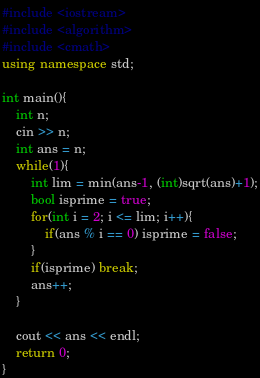Convert code to text. <code><loc_0><loc_0><loc_500><loc_500><_C++_>#include <iostream>
#include <algorithm>
#include <cmath>
using namespace std;

int main(){
    int n;
    cin >> n;
    int ans = n;
    while(1){
        int lim = min(ans-1, (int)sqrt(ans)+1);
        bool isprime = true;
        for(int i = 2; i <= lim; i++){
            if(ans % i == 0) isprime = false;
        }
        if(isprime) break;
        ans++;
    }

    cout << ans << endl;
    return 0;
}</code> 